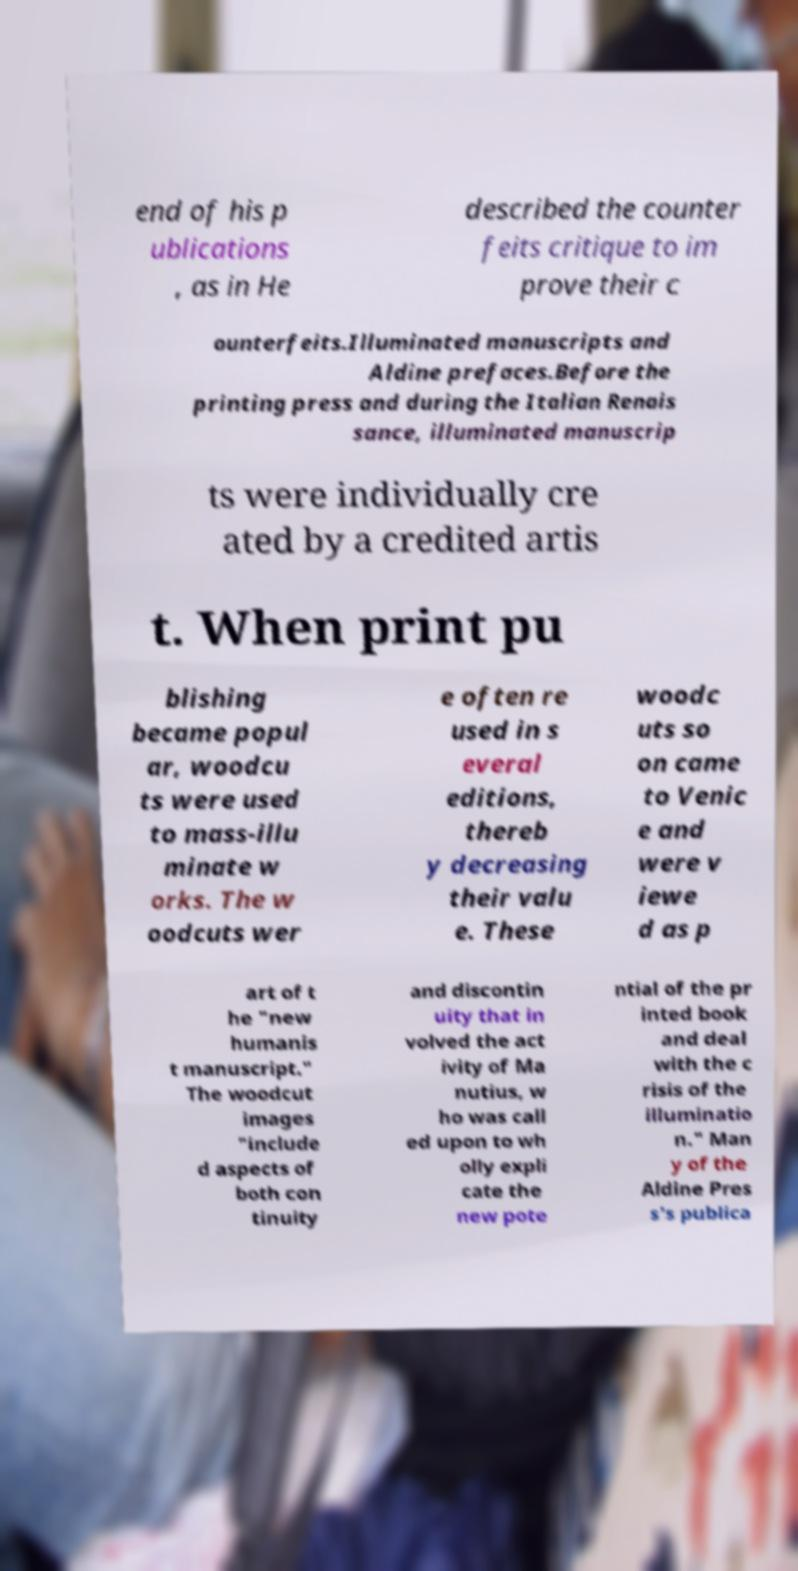Can you read and provide the text displayed in the image?This photo seems to have some interesting text. Can you extract and type it out for me? end of his p ublications , as in He described the counter feits critique to im prove their c ounterfeits.Illuminated manuscripts and Aldine prefaces.Before the printing press and during the Italian Renais sance, illuminated manuscrip ts were individually cre ated by a credited artis t. When print pu blishing became popul ar, woodcu ts were used to mass-illu minate w orks. The w oodcuts wer e often re used in s everal editions, thereb y decreasing their valu e. These woodc uts so on came to Venic e and were v iewe d as p art of t he "new humanis t manuscript." The woodcut images "include d aspects of both con tinuity and discontin uity that in volved the act ivity of Ma nutius, w ho was call ed upon to wh olly expli cate the new pote ntial of the pr inted book and deal with the c risis of the illuminatio n." Man y of the Aldine Pres s's publica 